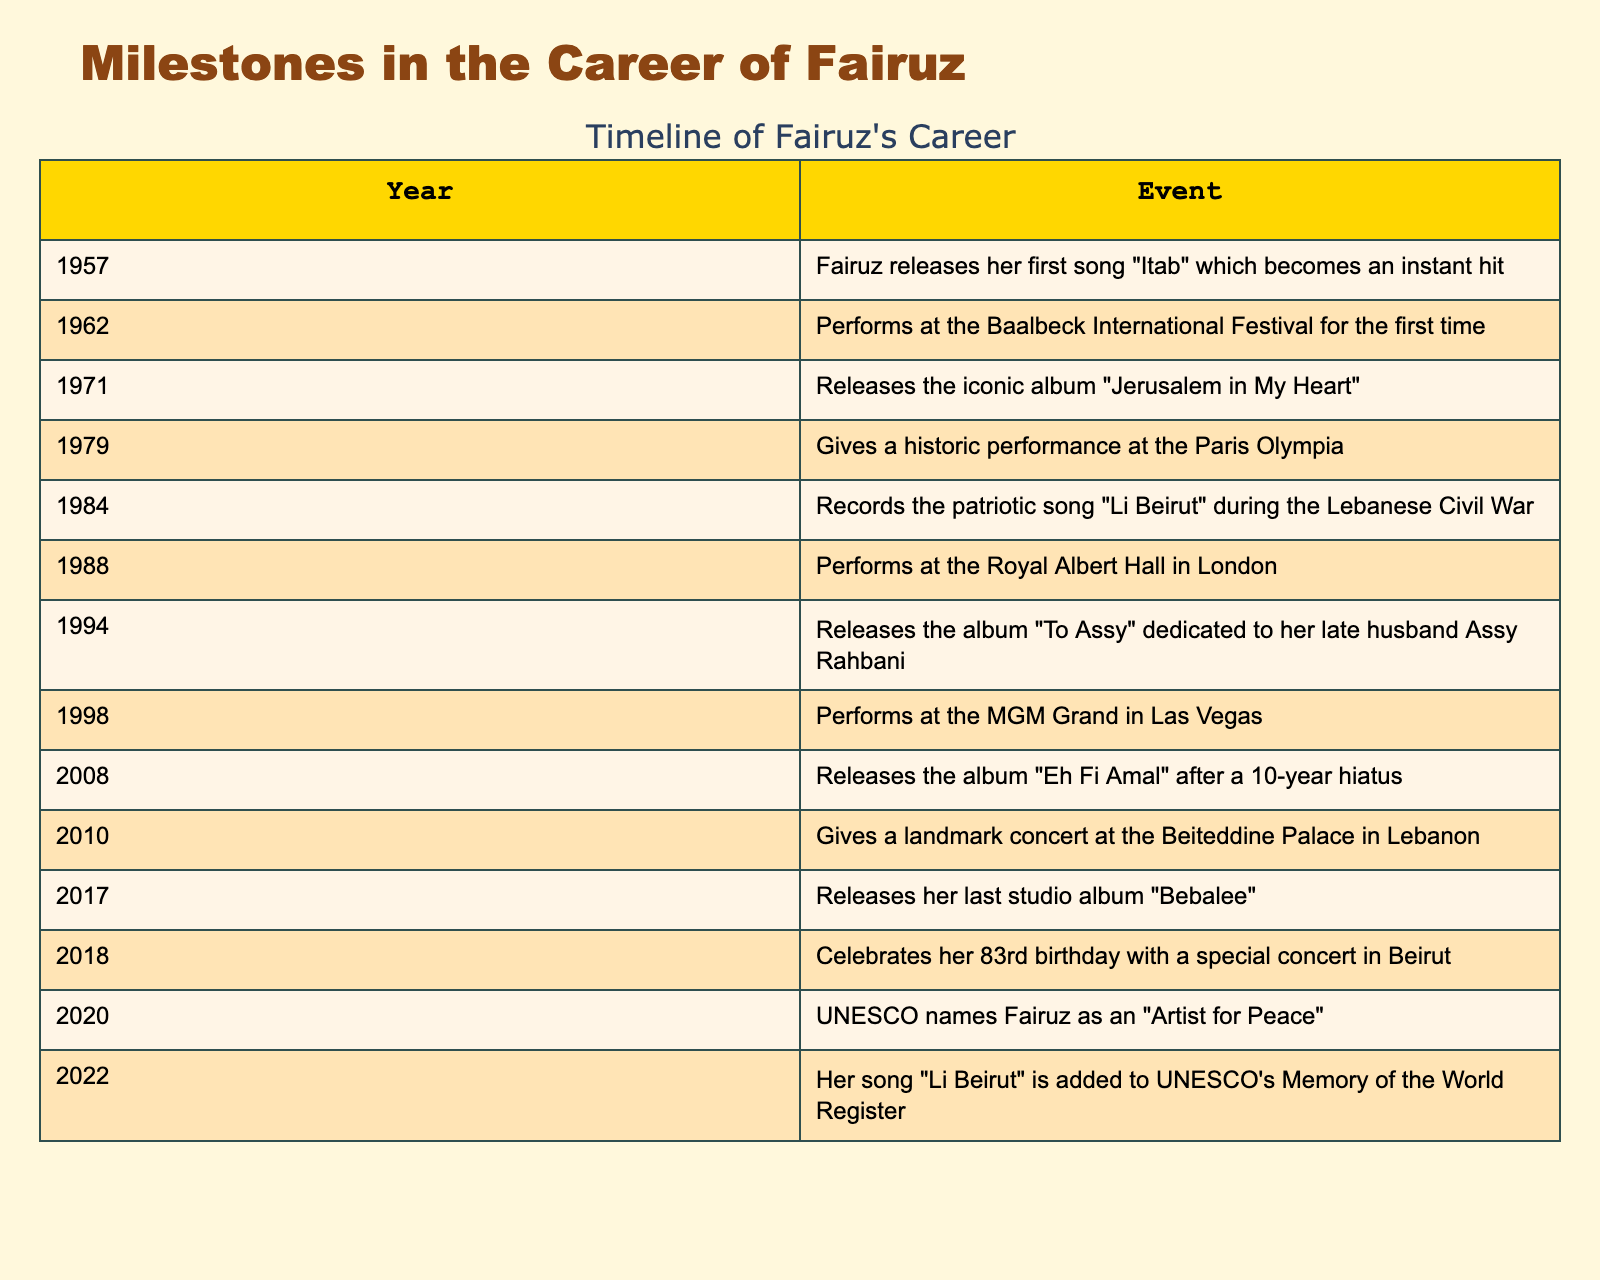What year did Fairuz release her first song? According to the table, Fairuz released her first song "Itab" in the year 1957.
Answer: 1957 In what year did Fairuz perform at the Baalbeck International Festival for the first time? The table shows that Fairuz performed at the Baalbeck International Festival for the first time in 1962.
Answer: 1962 How many years apart were the releases of "Jerusalem in My Heart" and "Li Beirut"? "Jerusalem in My Heart" was released in 1971 and "Li Beirut" was recorded in 1984. Calculating the difference: 1984 - 1971 = 13 years.
Answer: 13 years Did Fairuz perform at the Royal Albert Hall before or after her performance at the Paris Olympia? The table indicates that Fairuz gave a performance at the Paris Olympia in 1979 and then performed at the Royal Albert Hall in 1988. Therefore, she performed at the Olympia before the Royal Albert Hall.
Answer: Before Which event marks the last time she released a studio album? The table states that Fairuz released her last studio album "Bebalee" in 2017, making this the final studio album release in her career timeline.
Answer: 2017 How many significant performances took place in 1988 or later? Looking through the table, the significant performances after 1988 include: the MGM Grand in Las Vegas (1998), the concert at Beiteddine Palace (2010), and the performance celebrating her 83rd birthday (2018). Therefore, there are three performances.
Answer: 3 What is the significance of UNESCO naming Fairuz as an "Artist for Peace" in 2020? This recognition by UNESCO in 2020 highlights Fairuz's contribution to peace through her music, reflecting her iconic status and cultural influence in Lebanon and the world.
Answer: Cultural significance In how many years did Fairuz have a hiatus between her albums? According to the table, Fairuz released an album "Li Beirut" in 1984 and then released "Eh Fi Amal" in 2008. Calculating the years between these two releases: 2008 - 1984 = 24 years.
Answer: 24 years 